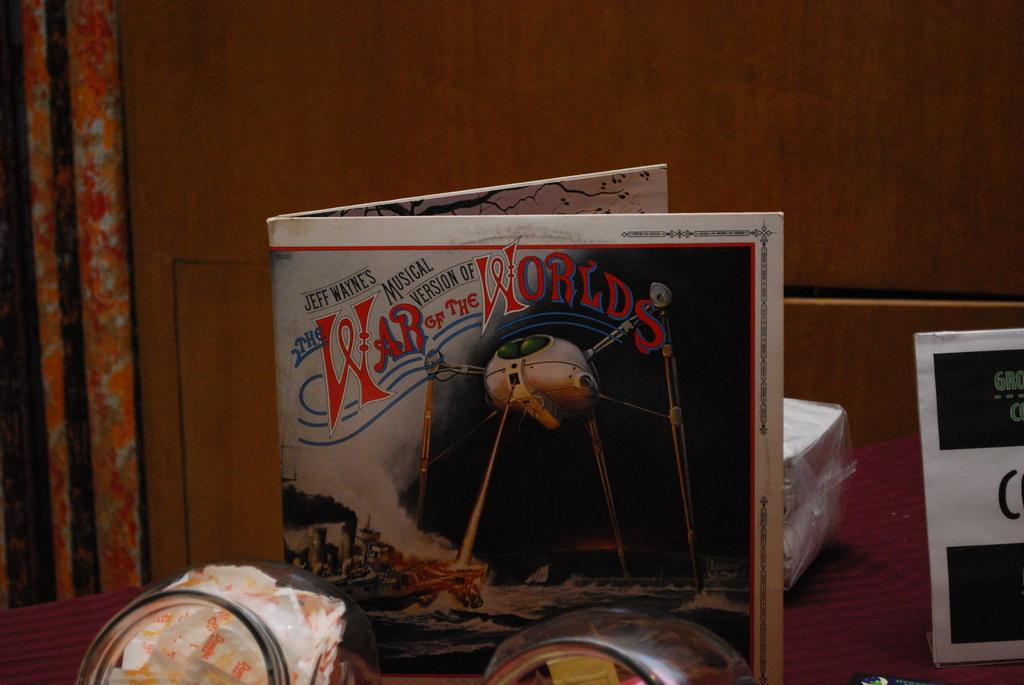<image>
Offer a succinct explanation of the picture presented. A book called the War of the Worlds is standing upright. 